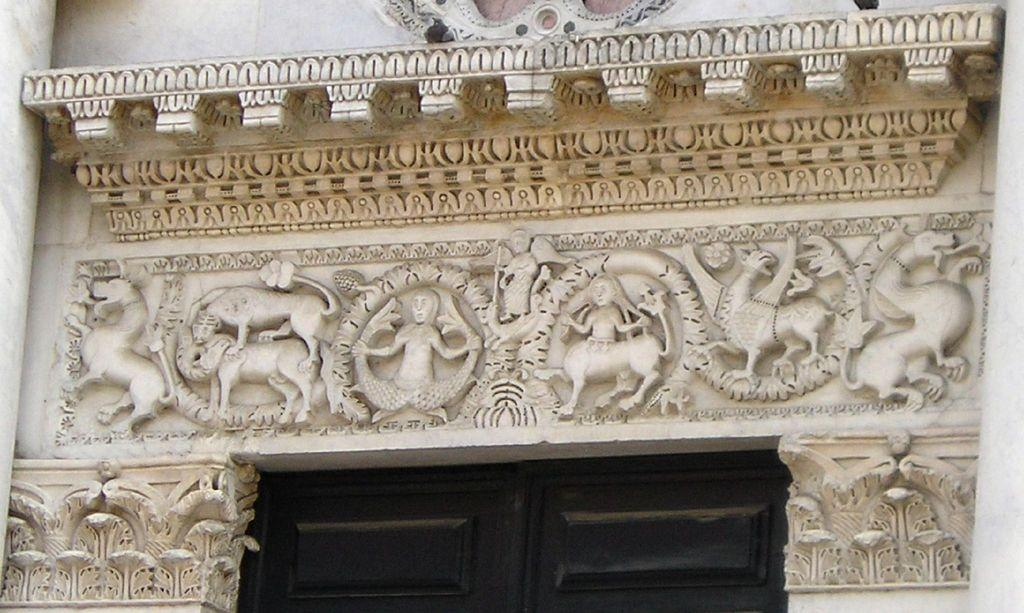What type of structure is visible in the image? There is a building in the image. What decorative element can be seen on the building? There is a sculpture on the wall of the building. What type of entrance is present in the image? There is a wooden door in the image. What is the average income of the people living in the building in the image? There is no information about the income of the people living in the building in the image. 